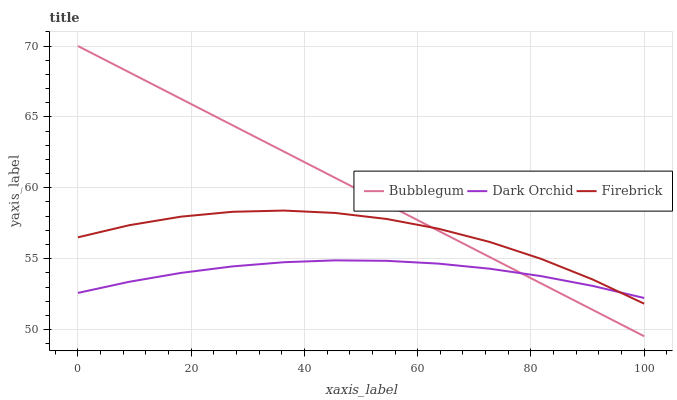Does Dark Orchid have the minimum area under the curve?
Answer yes or no. Yes. Does Bubblegum have the maximum area under the curve?
Answer yes or no. Yes. Does Bubblegum have the minimum area under the curve?
Answer yes or no. No. Does Dark Orchid have the maximum area under the curve?
Answer yes or no. No. Is Bubblegum the smoothest?
Answer yes or no. Yes. Is Firebrick the roughest?
Answer yes or no. Yes. Is Dark Orchid the smoothest?
Answer yes or no. No. Is Dark Orchid the roughest?
Answer yes or no. No. Does Dark Orchid have the lowest value?
Answer yes or no. No. Does Bubblegum have the highest value?
Answer yes or no. Yes. Does Dark Orchid have the highest value?
Answer yes or no. No. 